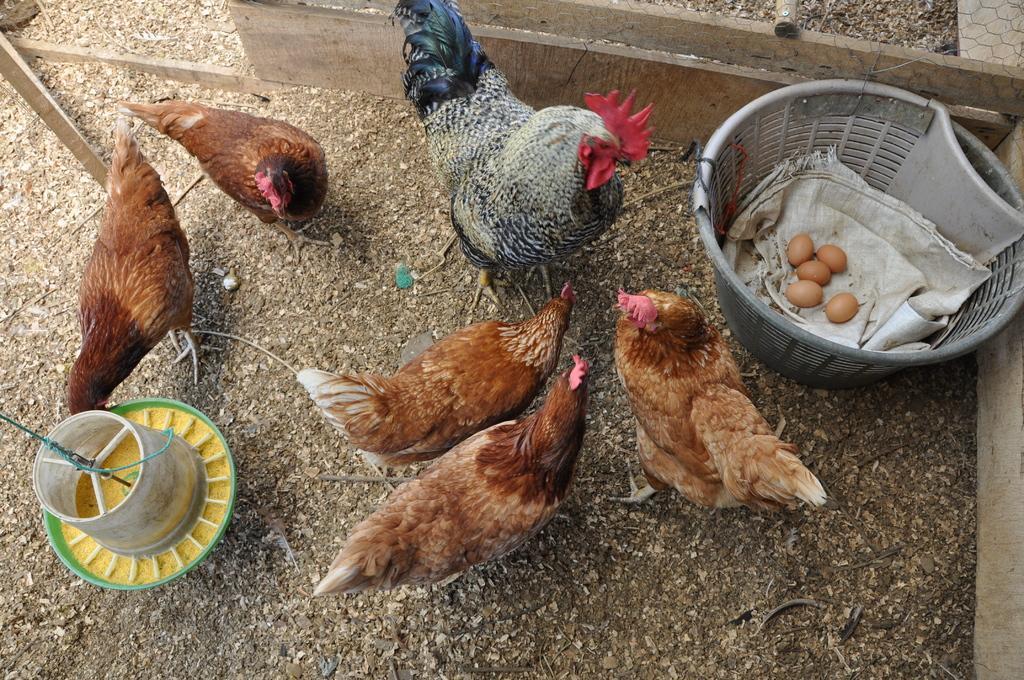How would you summarize this image in a sentence or two? In this picture, we see hens and a cock. On the right side, we see a grey basket containing five eggs and a plastic bag. Beside that, we see the wooden fence. On the left side, we see a plastic bowl in green color with yellow color grains. At the bottom, we see the soil, twigs and dry leaves. 